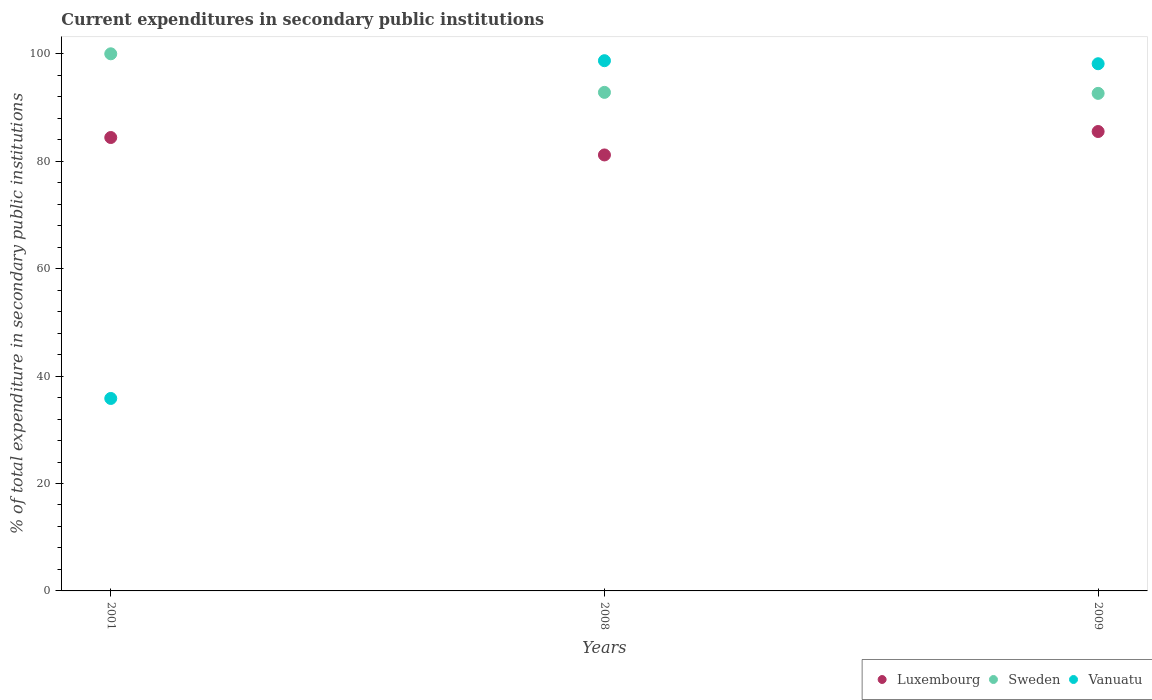What is the current expenditures in secondary public institutions in Luxembourg in 2009?
Make the answer very short. 85.53. Across all years, what is the maximum current expenditures in secondary public institutions in Sweden?
Provide a short and direct response. 100. Across all years, what is the minimum current expenditures in secondary public institutions in Vanuatu?
Your answer should be compact. 35.83. In which year was the current expenditures in secondary public institutions in Sweden maximum?
Offer a terse response. 2001. What is the total current expenditures in secondary public institutions in Vanuatu in the graph?
Give a very brief answer. 232.7. What is the difference between the current expenditures in secondary public institutions in Luxembourg in 2008 and that in 2009?
Provide a short and direct response. -4.36. What is the difference between the current expenditures in secondary public institutions in Luxembourg in 2001 and the current expenditures in secondary public institutions in Sweden in 2009?
Offer a very short reply. -8.22. What is the average current expenditures in secondary public institutions in Vanuatu per year?
Your response must be concise. 77.57. In the year 2009, what is the difference between the current expenditures in secondary public institutions in Sweden and current expenditures in secondary public institutions in Vanuatu?
Provide a succinct answer. -5.52. In how many years, is the current expenditures in secondary public institutions in Luxembourg greater than 80 %?
Your response must be concise. 3. What is the ratio of the current expenditures in secondary public institutions in Luxembourg in 2001 to that in 2008?
Make the answer very short. 1.04. Is the current expenditures in secondary public institutions in Vanuatu in 2008 less than that in 2009?
Give a very brief answer. No. What is the difference between the highest and the second highest current expenditures in secondary public institutions in Vanuatu?
Keep it short and to the point. 0.57. What is the difference between the highest and the lowest current expenditures in secondary public institutions in Sweden?
Offer a very short reply. 7.37. Is the sum of the current expenditures in secondary public institutions in Sweden in 2001 and 2008 greater than the maximum current expenditures in secondary public institutions in Vanuatu across all years?
Give a very brief answer. Yes. What is the difference between two consecutive major ticks on the Y-axis?
Offer a very short reply. 20. Does the graph contain any zero values?
Your answer should be very brief. No. Does the graph contain grids?
Give a very brief answer. No. Where does the legend appear in the graph?
Your answer should be very brief. Bottom right. How many legend labels are there?
Provide a short and direct response. 3. What is the title of the graph?
Provide a short and direct response. Current expenditures in secondary public institutions. Does "Latvia" appear as one of the legend labels in the graph?
Your answer should be compact. No. What is the label or title of the Y-axis?
Keep it short and to the point. % of total expenditure in secondary public institutions. What is the % of total expenditure in secondary public institutions in Luxembourg in 2001?
Your answer should be compact. 84.42. What is the % of total expenditure in secondary public institutions in Vanuatu in 2001?
Offer a very short reply. 35.83. What is the % of total expenditure in secondary public institutions of Luxembourg in 2008?
Your response must be concise. 81.17. What is the % of total expenditure in secondary public institutions of Sweden in 2008?
Offer a terse response. 92.82. What is the % of total expenditure in secondary public institutions of Vanuatu in 2008?
Keep it short and to the point. 98.72. What is the % of total expenditure in secondary public institutions of Luxembourg in 2009?
Give a very brief answer. 85.53. What is the % of total expenditure in secondary public institutions in Sweden in 2009?
Keep it short and to the point. 92.63. What is the % of total expenditure in secondary public institutions of Vanuatu in 2009?
Offer a terse response. 98.15. Across all years, what is the maximum % of total expenditure in secondary public institutions in Luxembourg?
Your answer should be compact. 85.53. Across all years, what is the maximum % of total expenditure in secondary public institutions in Sweden?
Offer a very short reply. 100. Across all years, what is the maximum % of total expenditure in secondary public institutions of Vanuatu?
Your answer should be very brief. 98.72. Across all years, what is the minimum % of total expenditure in secondary public institutions of Luxembourg?
Your response must be concise. 81.17. Across all years, what is the minimum % of total expenditure in secondary public institutions in Sweden?
Provide a short and direct response. 92.63. Across all years, what is the minimum % of total expenditure in secondary public institutions in Vanuatu?
Make the answer very short. 35.83. What is the total % of total expenditure in secondary public institutions in Luxembourg in the graph?
Ensure brevity in your answer.  251.12. What is the total % of total expenditure in secondary public institutions of Sweden in the graph?
Give a very brief answer. 285.45. What is the total % of total expenditure in secondary public institutions in Vanuatu in the graph?
Your answer should be very brief. 232.7. What is the difference between the % of total expenditure in secondary public institutions in Luxembourg in 2001 and that in 2008?
Keep it short and to the point. 3.25. What is the difference between the % of total expenditure in secondary public institutions of Sweden in 2001 and that in 2008?
Your answer should be very brief. 7.18. What is the difference between the % of total expenditure in secondary public institutions in Vanuatu in 2001 and that in 2008?
Ensure brevity in your answer.  -62.89. What is the difference between the % of total expenditure in secondary public institutions of Luxembourg in 2001 and that in 2009?
Provide a succinct answer. -1.12. What is the difference between the % of total expenditure in secondary public institutions of Sweden in 2001 and that in 2009?
Ensure brevity in your answer.  7.37. What is the difference between the % of total expenditure in secondary public institutions in Vanuatu in 2001 and that in 2009?
Provide a succinct answer. -62.32. What is the difference between the % of total expenditure in secondary public institutions in Luxembourg in 2008 and that in 2009?
Ensure brevity in your answer.  -4.36. What is the difference between the % of total expenditure in secondary public institutions of Sweden in 2008 and that in 2009?
Offer a very short reply. 0.19. What is the difference between the % of total expenditure in secondary public institutions of Vanuatu in 2008 and that in 2009?
Provide a succinct answer. 0.57. What is the difference between the % of total expenditure in secondary public institutions in Luxembourg in 2001 and the % of total expenditure in secondary public institutions in Sweden in 2008?
Your answer should be very brief. -8.4. What is the difference between the % of total expenditure in secondary public institutions of Luxembourg in 2001 and the % of total expenditure in secondary public institutions of Vanuatu in 2008?
Your answer should be very brief. -14.3. What is the difference between the % of total expenditure in secondary public institutions of Sweden in 2001 and the % of total expenditure in secondary public institutions of Vanuatu in 2008?
Your answer should be compact. 1.28. What is the difference between the % of total expenditure in secondary public institutions of Luxembourg in 2001 and the % of total expenditure in secondary public institutions of Sweden in 2009?
Keep it short and to the point. -8.22. What is the difference between the % of total expenditure in secondary public institutions in Luxembourg in 2001 and the % of total expenditure in secondary public institutions in Vanuatu in 2009?
Provide a short and direct response. -13.74. What is the difference between the % of total expenditure in secondary public institutions of Sweden in 2001 and the % of total expenditure in secondary public institutions of Vanuatu in 2009?
Ensure brevity in your answer.  1.85. What is the difference between the % of total expenditure in secondary public institutions in Luxembourg in 2008 and the % of total expenditure in secondary public institutions in Sweden in 2009?
Your response must be concise. -11.46. What is the difference between the % of total expenditure in secondary public institutions of Luxembourg in 2008 and the % of total expenditure in secondary public institutions of Vanuatu in 2009?
Ensure brevity in your answer.  -16.98. What is the difference between the % of total expenditure in secondary public institutions of Sweden in 2008 and the % of total expenditure in secondary public institutions of Vanuatu in 2009?
Your response must be concise. -5.33. What is the average % of total expenditure in secondary public institutions of Luxembourg per year?
Provide a short and direct response. 83.71. What is the average % of total expenditure in secondary public institutions in Sweden per year?
Give a very brief answer. 95.15. What is the average % of total expenditure in secondary public institutions of Vanuatu per year?
Provide a succinct answer. 77.57. In the year 2001, what is the difference between the % of total expenditure in secondary public institutions of Luxembourg and % of total expenditure in secondary public institutions of Sweden?
Your answer should be very brief. -15.58. In the year 2001, what is the difference between the % of total expenditure in secondary public institutions in Luxembourg and % of total expenditure in secondary public institutions in Vanuatu?
Your response must be concise. 48.58. In the year 2001, what is the difference between the % of total expenditure in secondary public institutions in Sweden and % of total expenditure in secondary public institutions in Vanuatu?
Keep it short and to the point. 64.17. In the year 2008, what is the difference between the % of total expenditure in secondary public institutions of Luxembourg and % of total expenditure in secondary public institutions of Sweden?
Your response must be concise. -11.65. In the year 2008, what is the difference between the % of total expenditure in secondary public institutions in Luxembourg and % of total expenditure in secondary public institutions in Vanuatu?
Offer a terse response. -17.55. In the year 2008, what is the difference between the % of total expenditure in secondary public institutions of Sweden and % of total expenditure in secondary public institutions of Vanuatu?
Provide a short and direct response. -5.9. In the year 2009, what is the difference between the % of total expenditure in secondary public institutions of Luxembourg and % of total expenditure in secondary public institutions of Sweden?
Give a very brief answer. -7.1. In the year 2009, what is the difference between the % of total expenditure in secondary public institutions in Luxembourg and % of total expenditure in secondary public institutions in Vanuatu?
Provide a succinct answer. -12.62. In the year 2009, what is the difference between the % of total expenditure in secondary public institutions of Sweden and % of total expenditure in secondary public institutions of Vanuatu?
Make the answer very short. -5.52. What is the ratio of the % of total expenditure in secondary public institutions of Luxembourg in 2001 to that in 2008?
Your answer should be compact. 1.04. What is the ratio of the % of total expenditure in secondary public institutions of Sweden in 2001 to that in 2008?
Your response must be concise. 1.08. What is the ratio of the % of total expenditure in secondary public institutions in Vanuatu in 2001 to that in 2008?
Offer a terse response. 0.36. What is the ratio of the % of total expenditure in secondary public institutions in Luxembourg in 2001 to that in 2009?
Offer a terse response. 0.99. What is the ratio of the % of total expenditure in secondary public institutions in Sweden in 2001 to that in 2009?
Provide a succinct answer. 1.08. What is the ratio of the % of total expenditure in secondary public institutions of Vanuatu in 2001 to that in 2009?
Your answer should be compact. 0.37. What is the ratio of the % of total expenditure in secondary public institutions of Luxembourg in 2008 to that in 2009?
Offer a very short reply. 0.95. What is the ratio of the % of total expenditure in secondary public institutions in Sweden in 2008 to that in 2009?
Your answer should be compact. 1. What is the ratio of the % of total expenditure in secondary public institutions of Vanuatu in 2008 to that in 2009?
Your response must be concise. 1.01. What is the difference between the highest and the second highest % of total expenditure in secondary public institutions in Luxembourg?
Your answer should be compact. 1.12. What is the difference between the highest and the second highest % of total expenditure in secondary public institutions of Sweden?
Offer a terse response. 7.18. What is the difference between the highest and the second highest % of total expenditure in secondary public institutions of Vanuatu?
Your answer should be very brief. 0.57. What is the difference between the highest and the lowest % of total expenditure in secondary public institutions in Luxembourg?
Your answer should be compact. 4.36. What is the difference between the highest and the lowest % of total expenditure in secondary public institutions of Sweden?
Ensure brevity in your answer.  7.37. What is the difference between the highest and the lowest % of total expenditure in secondary public institutions of Vanuatu?
Your answer should be compact. 62.89. 